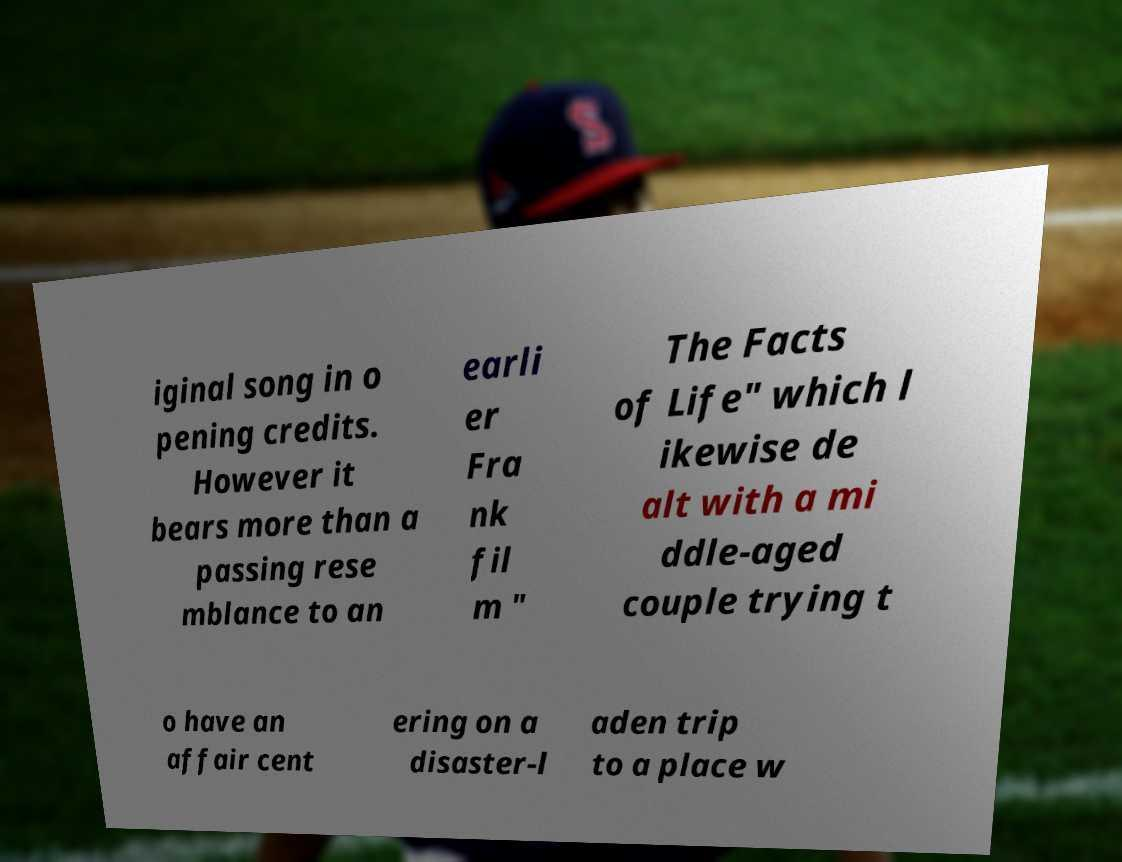Can you accurately transcribe the text from the provided image for me? iginal song in o pening credits. However it bears more than a passing rese mblance to an earli er Fra nk fil m " The Facts of Life" which l ikewise de alt with a mi ddle-aged couple trying t o have an affair cent ering on a disaster-l aden trip to a place w 